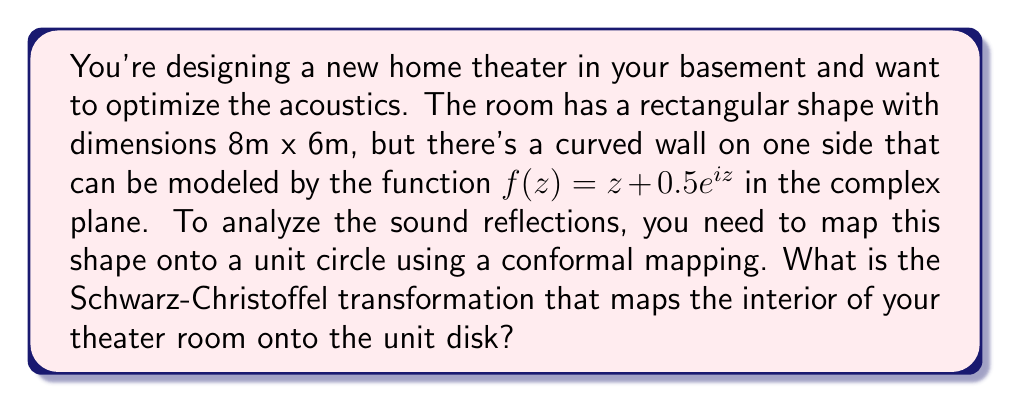Give your solution to this math problem. To solve this problem, we'll follow these steps:

1) First, we need to understand that the Schwarz-Christoffel transformation is used to map the interior of a polygon onto the upper half-plane or the unit disk. In this case, we're mapping to the unit disk.

2) The general form of the Schwarz-Christoffel transformation for mapping to the unit disk is:

   $$w = f(z) = A \int \prod_{k=1}^n (1 - \frac{z}{z_k})^{\alpha_k - 1} dz + B$$

   where $z_k$ are the prevertices on the unit circle, $\alpha_k \pi$ are the interior angles of the polygon, and $A$ and $B$ are complex constants.

3) In our case, we have a rectangle with a curved side. We can approximate this as a polygon with five sides: four for the rectangle and one for the curved side.

4) The interior angles of a rectangle are all $\frac{\pi}{2}$. The curved side can be approximated as a single straight line with an interior angle slightly less than $\pi$, let's say $\frac{5\pi}{6}$.

5) So our $\alpha_k$ values are:
   $\alpha_1 = \alpha_2 = \alpha_3 = \alpha_4 = \frac{1}{2}$ and $\alpha_5 = \frac{5}{6}$

6) Substituting these into our formula:

   $$w = A \int (1-\frac{z}{z_1})^{-\frac{1}{2}} (1-\frac{z}{z_2})^{-\frac{1}{2}} (1-\frac{z}{z_3})^{-\frac{1}{2}} (1-\frac{z}{z_4})^{-\frac{1}{2}} (1-\frac{z}{z_5})^{-\frac{1}{6}} dz + B$$

7) The exact values of $z_k$ depend on the specific dimensions and curve of your room, which would require more detailed calculations. However, this is the general form of the Schwarz-Christoffel transformation for your theater room.

8) To fully determine the transformation, you would need to solve for the constants $A$ and $B$ using the specific dimensions of your room.
Answer: The Schwarz-Christoffel transformation that maps the interior of the theater room onto the unit disk is:

$$w = A \int (1-\frac{z}{z_1})^{-\frac{1}{2}} (1-\frac{z}{z_2})^{-\frac{1}{2}} (1-\frac{z}{z_3})^{-\frac{1}{2}} (1-\frac{z}{z_4})^{-\frac{1}{2}} (1-\frac{z}{z_5})^{-\frac{1}{6}} dz + B$$

where $z_k$ are the prevertices on the unit circle, and $A$ and $B$ are complex constants to be determined based on the specific room dimensions. 